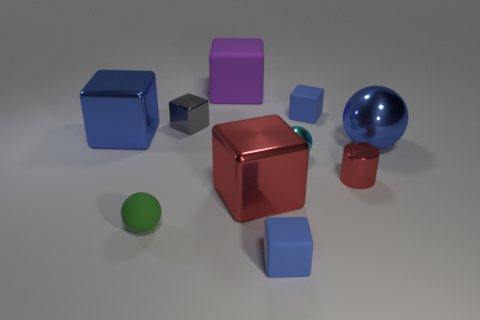Is there any other thing that has the same shape as the gray metal object?
Ensure brevity in your answer.  Yes. What number of objects are either big brown rubber blocks or big red objects?
Make the answer very short. 1. What is the size of the cyan object that is the same shape as the small green matte thing?
Offer a very short reply. Small. What number of other objects are there of the same color as the large metal ball?
Provide a succinct answer. 3. What number of blocks are either big red shiny things or purple objects?
Make the answer very short. 2. There is a small rubber object that is behind the blue cube that is left of the small green object; what color is it?
Your answer should be compact. Blue. The gray object has what shape?
Offer a very short reply. Cube. There is a cylinder in front of the blue metal sphere; is its size the same as the tiny green rubber sphere?
Your answer should be compact. Yes. Are there any cylinders made of the same material as the large red object?
Ensure brevity in your answer.  Yes. How many things are things that are to the left of the gray object or shiny spheres?
Give a very brief answer. 4. 